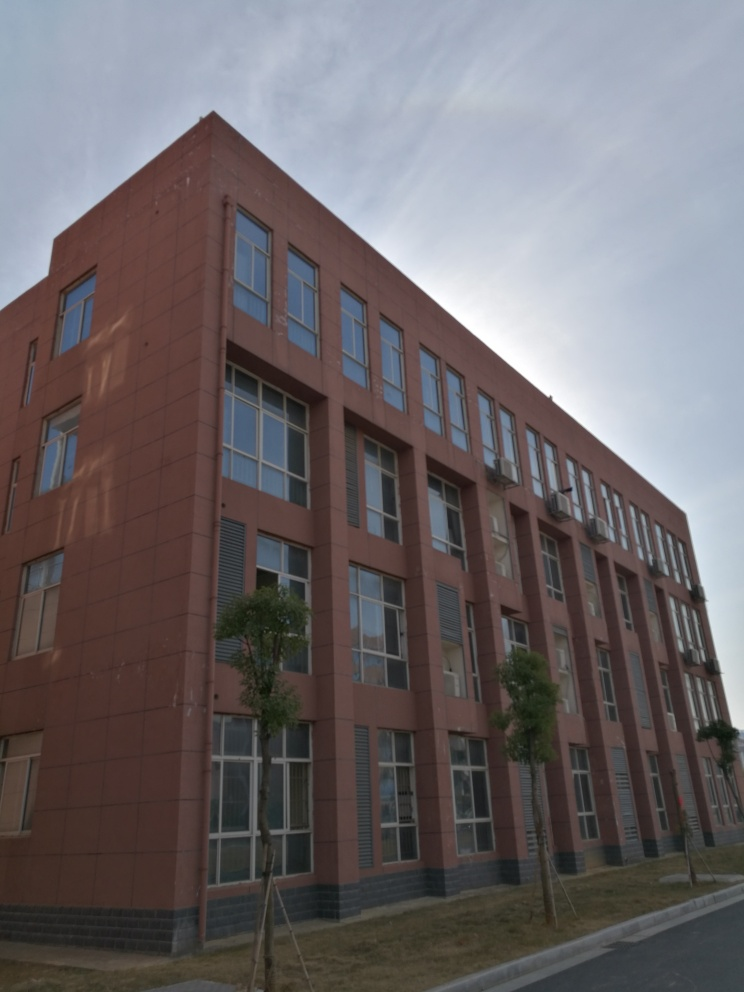What architectural style is represented in this building? The building showcases a contemporary architectural style with a utilitarian approach, characterized by its simple, geometric form and the use of modern materials, such as the red and grey facade panels. 